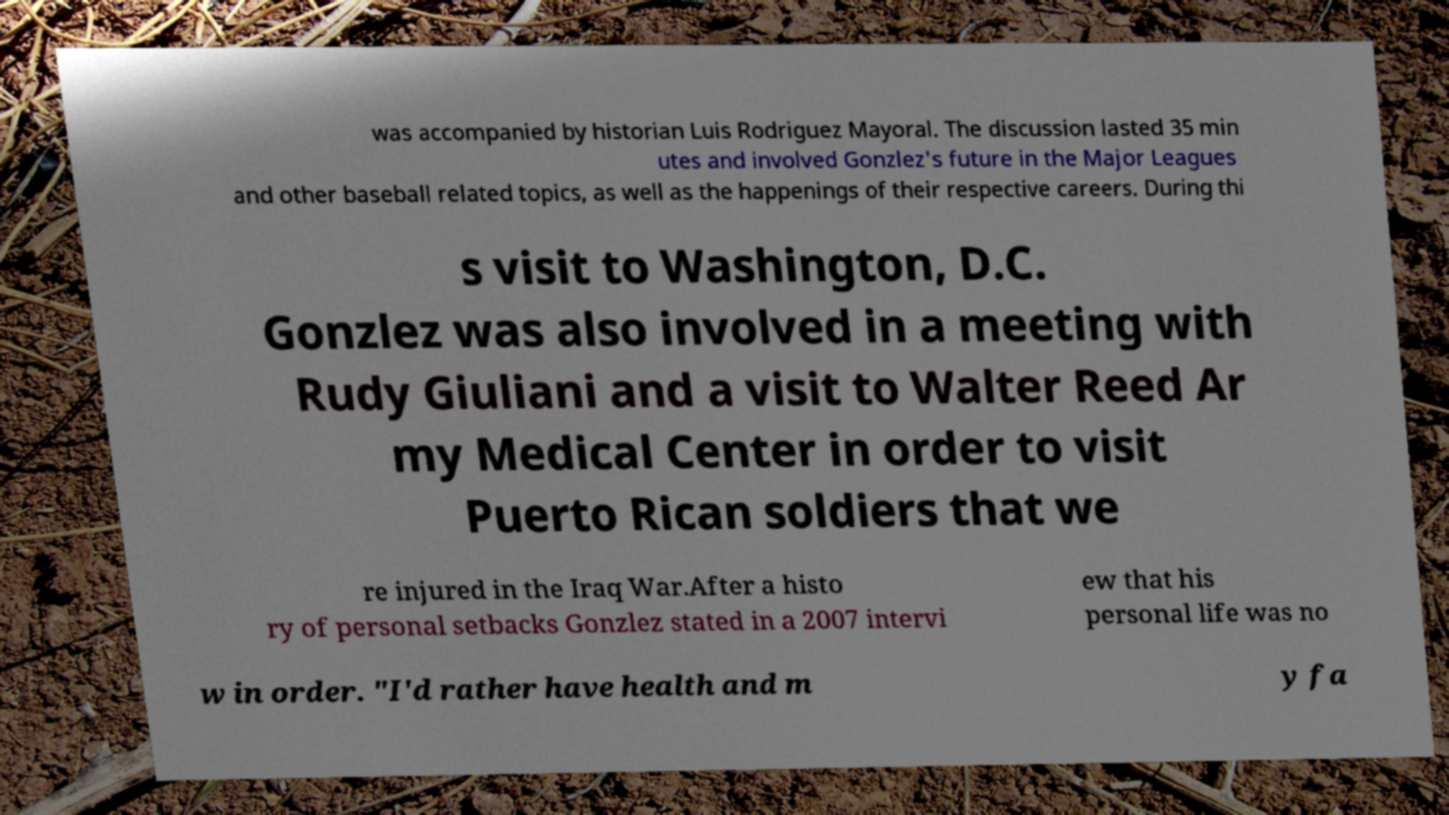Could you assist in decoding the text presented in this image and type it out clearly? was accompanied by historian Luis Rodriguez Mayoral. The discussion lasted 35 min utes and involved Gonzlez's future in the Major Leagues and other baseball related topics, as well as the happenings of their respective careers. During thi s visit to Washington, D.C. Gonzlez was also involved in a meeting with Rudy Giuliani and a visit to Walter Reed Ar my Medical Center in order to visit Puerto Rican soldiers that we re injured in the Iraq War.After a histo ry of personal setbacks Gonzlez stated in a 2007 intervi ew that his personal life was no w in order. "I'd rather have health and m y fa 